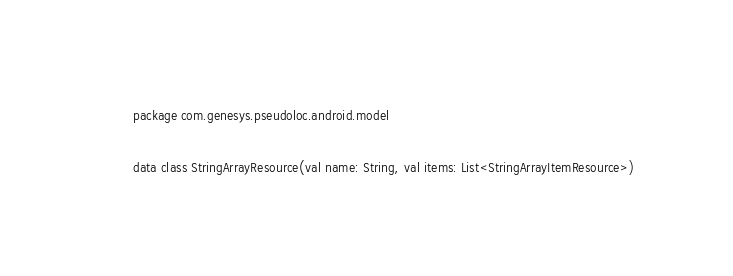<code> <loc_0><loc_0><loc_500><loc_500><_Kotlin_>package com.genesys.pseudoloc.android.model

data class StringArrayResource(val name: String, val items: List<StringArrayItemResource>)</code> 